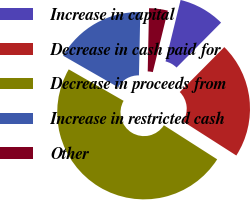<chart> <loc_0><loc_0><loc_500><loc_500><pie_chart><fcel>Increase in capital<fcel>Decrease in cash paid for<fcel>Decrease in proceeds from<fcel>Increase in restricted cash<fcel>Other<nl><fcel>8.61%<fcel>21.62%<fcel>49.23%<fcel>17.05%<fcel>3.48%<nl></chart> 